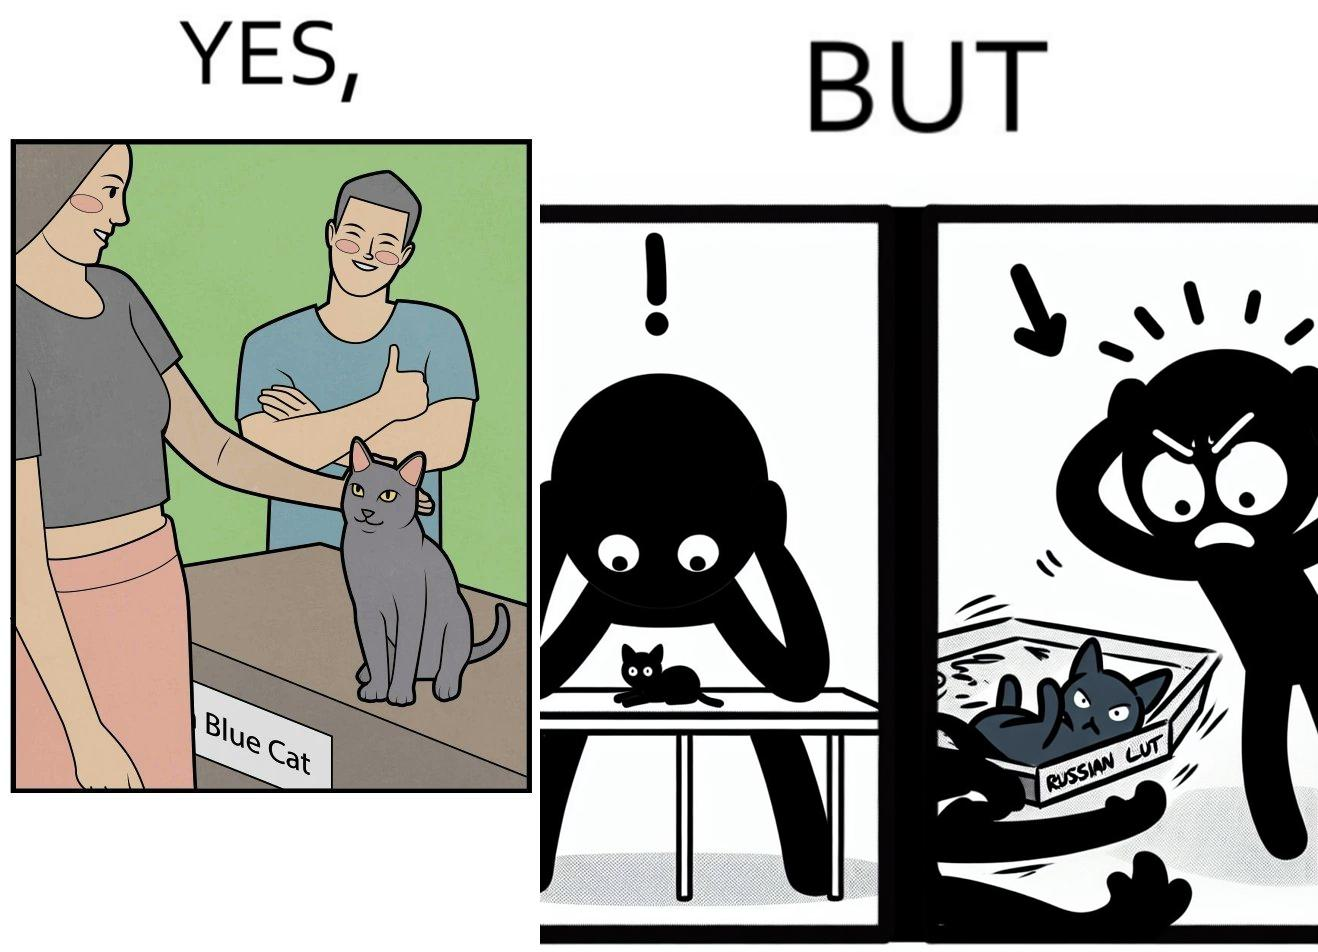Does this image contain satire or humor? Yes, this image is satirical. 